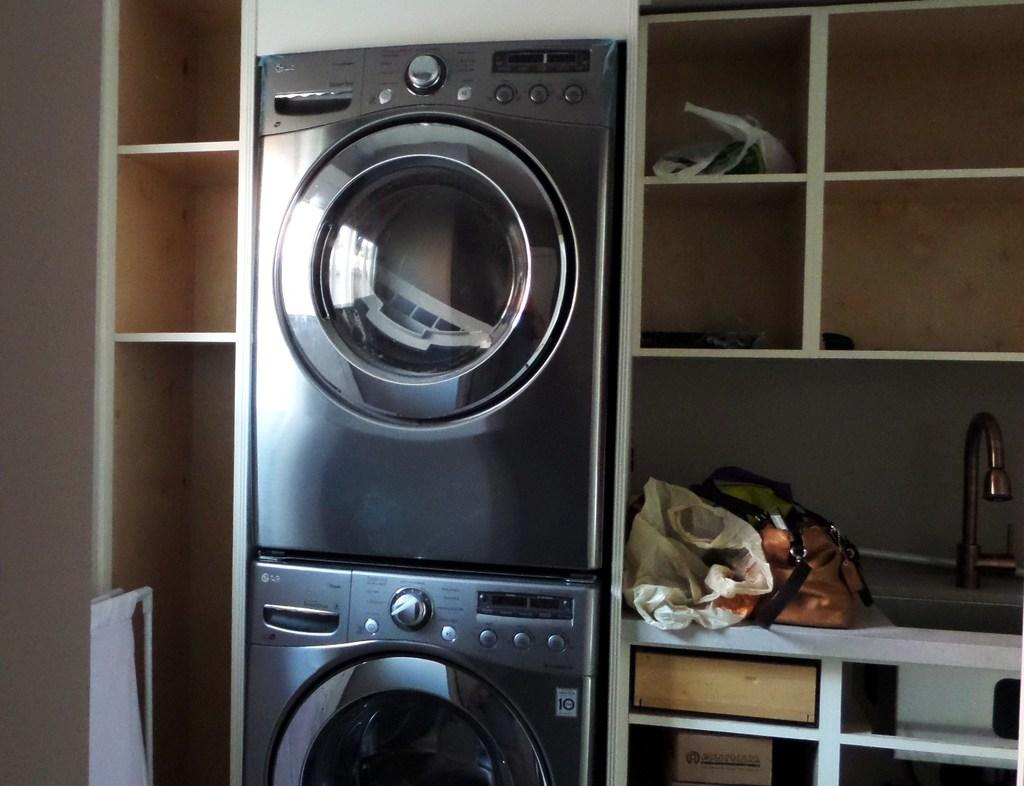How many washing machines can be seen in the image? There are two washing machines in the image. Where are the washing machines located in relation to the shelves? The washing machines are kept between shelves in the image. What is located beside the sink in the image? There is a bag beside the sink in the image. What else can be found on the shelves in the image? There are other objects on the shelves in the image. Can you describe the bee's role in the washing machine's operation in the image? There is no bee present in the image, so it cannot be described as having a role in the washing machine's operation. 